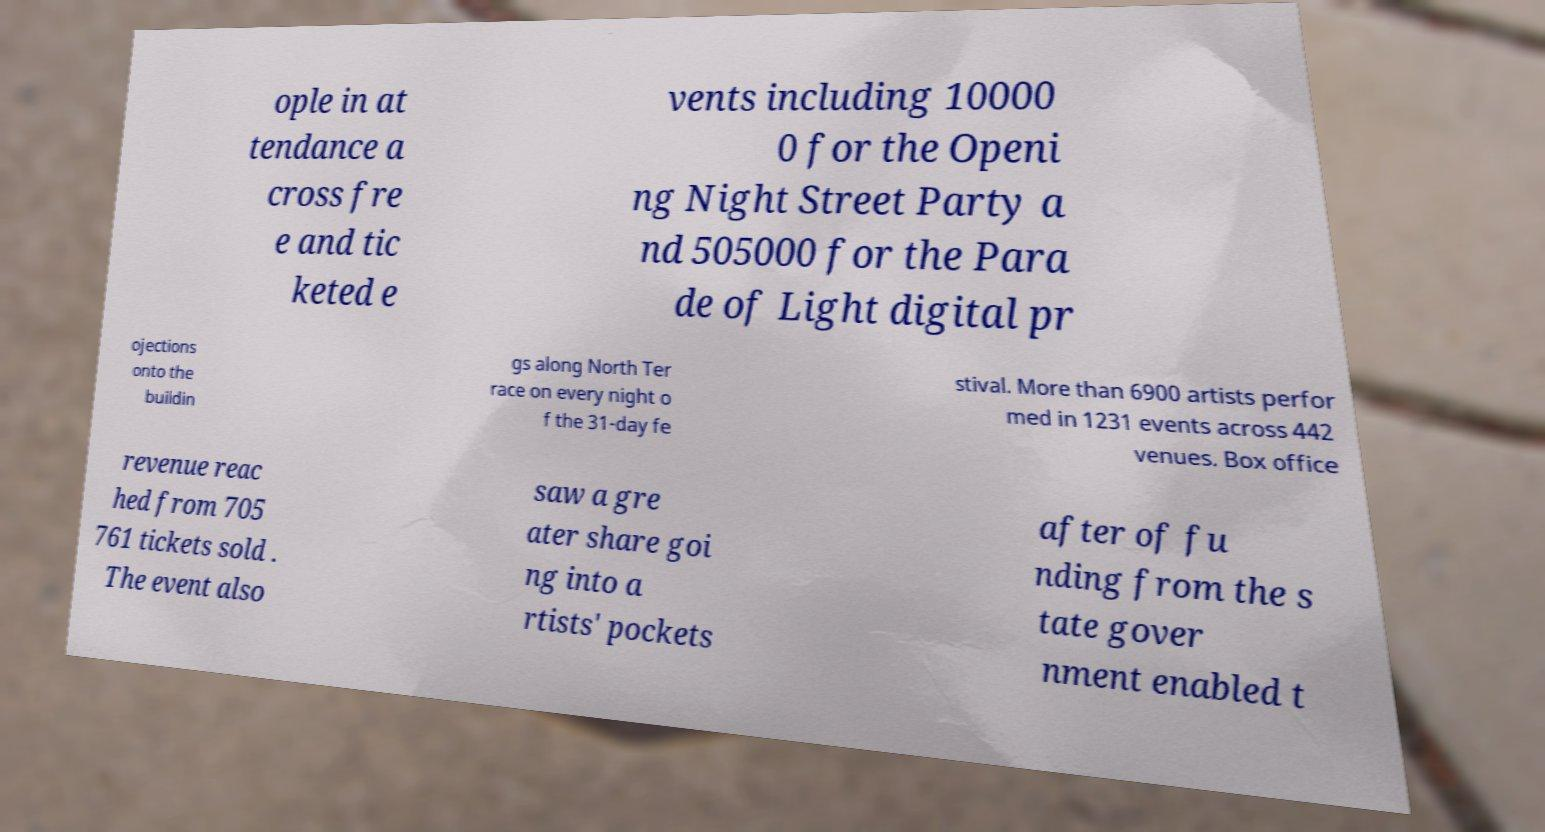Please read and relay the text visible in this image. What does it say? ople in at tendance a cross fre e and tic keted e vents including 10000 0 for the Openi ng Night Street Party a nd 505000 for the Para de of Light digital pr ojections onto the buildin gs along North Ter race on every night o f the 31-day fe stival. More than 6900 artists perfor med in 1231 events across 442 venues. Box office revenue reac hed from 705 761 tickets sold . The event also saw a gre ater share goi ng into a rtists' pockets after of fu nding from the s tate gover nment enabled t 